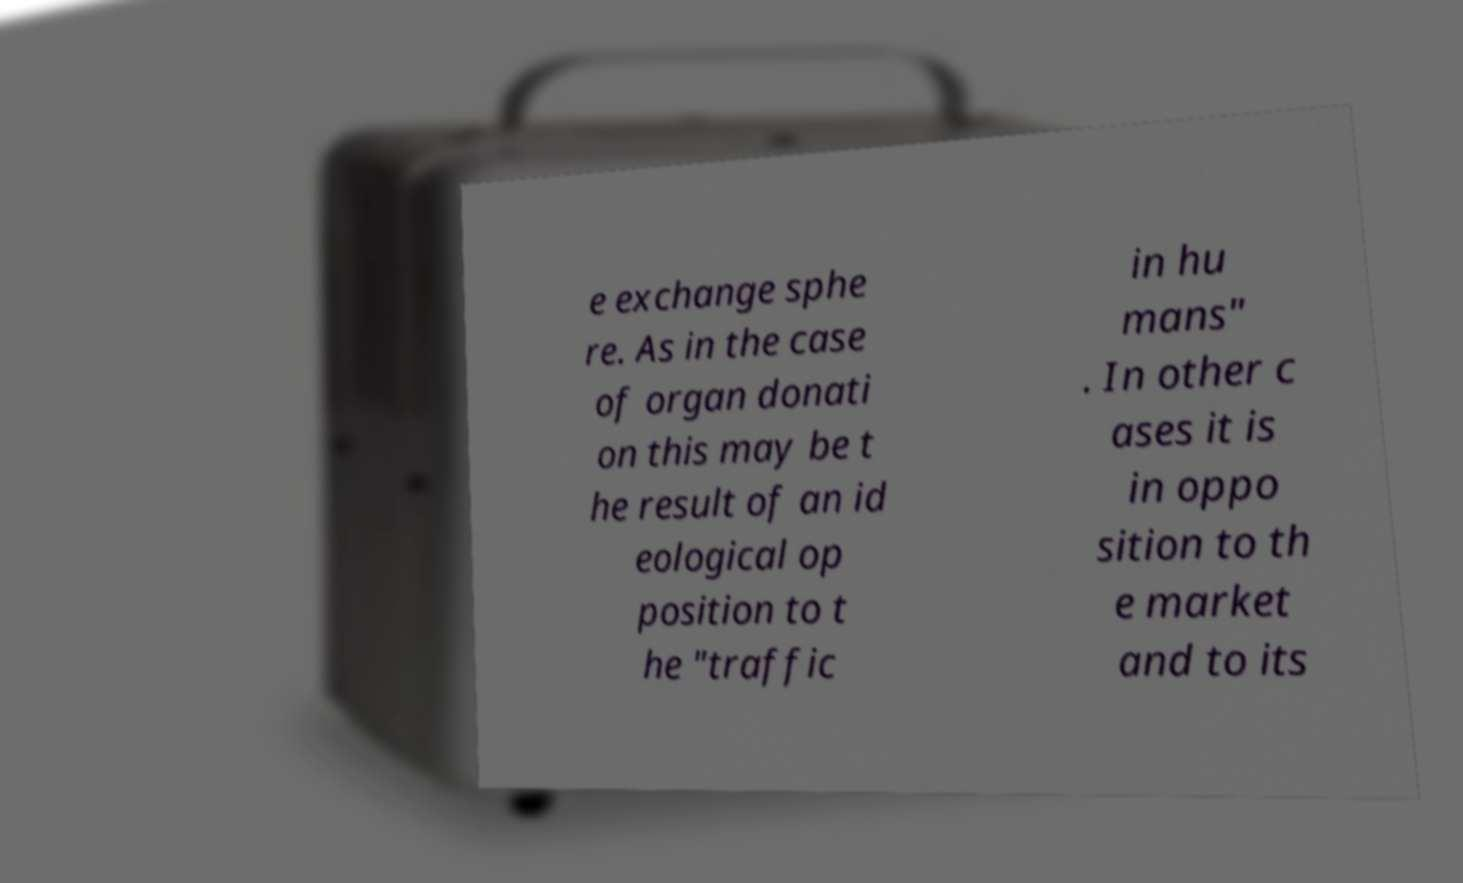Please read and relay the text visible in this image. What does it say? e exchange sphe re. As in the case of organ donati on this may be t he result of an id eological op position to t he "traffic in hu mans" . In other c ases it is in oppo sition to th e market and to its 